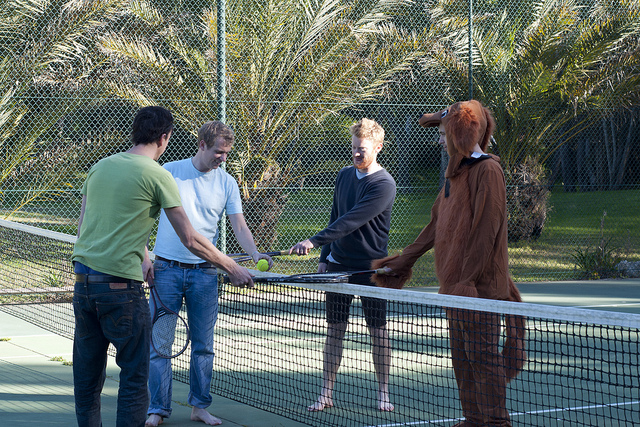Can you describe what the people in the image are doing? The people in the image seem to be engaged in a playful or casual activity on a tennis court. One person is dressed in a brown dog costume, and they are all interacting near the net, possibly discussing or deciding something related to a game. What do you think they could be talking about? It's likely that they are talking about the game they are about to play or have just finished playing. They might be discussing the rules, deciding on teams, or maybe even just joking around after a fun match. 